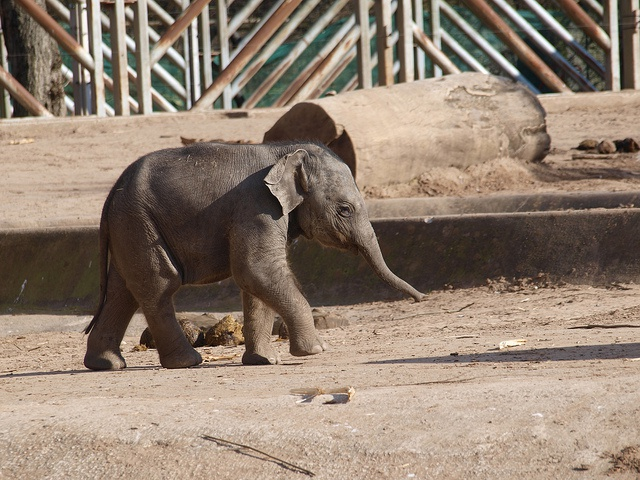Describe the objects in this image and their specific colors. I can see a elephant in black, gray, and darkgray tones in this image. 